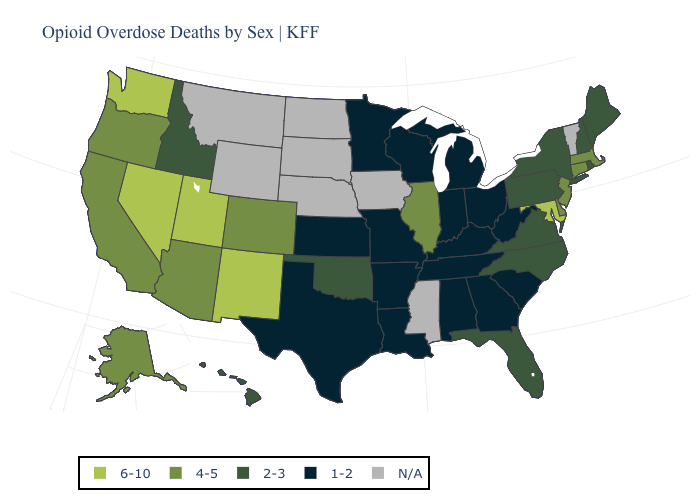Is the legend a continuous bar?
Concise answer only. No. What is the value of Alaska?
Write a very short answer. 4-5. What is the lowest value in the MidWest?
Short answer required. 1-2. Does Oregon have the highest value in the USA?
Be succinct. No. Does Illinois have the lowest value in the MidWest?
Short answer required. No. What is the value of North Dakota?
Answer briefly. N/A. What is the highest value in states that border Wisconsin?
Keep it brief. 4-5. Does Utah have the highest value in the USA?
Write a very short answer. Yes. What is the lowest value in the USA?
Be succinct. 1-2. Does Arkansas have the highest value in the USA?
Be succinct. No. Is the legend a continuous bar?
Give a very brief answer. No. Among the states that border Tennessee , which have the highest value?
Write a very short answer. North Carolina, Virginia. 